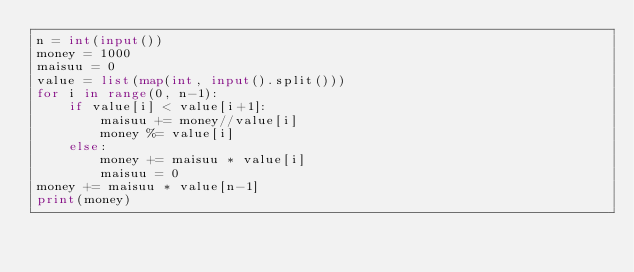<code> <loc_0><loc_0><loc_500><loc_500><_Python_>n = int(input())
money = 1000
maisuu = 0
value = list(map(int, input().split()))
for i in range(0, n-1):
    if value[i] < value[i+1]:
        maisuu += money//value[i]
        money %= value[i]
    else:
        money += maisuu * value[i]
        maisuu = 0
money += maisuu * value[n-1]
print(money)</code> 